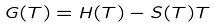Convert formula to latex. <formula><loc_0><loc_0><loc_500><loc_500>G ( T ) = H ( T ) - S ( T ) T</formula> 